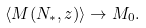Convert formula to latex. <formula><loc_0><loc_0><loc_500><loc_500>\langle M ( N _ { * } , z ) \rangle \rightarrow M _ { 0 } .</formula> 